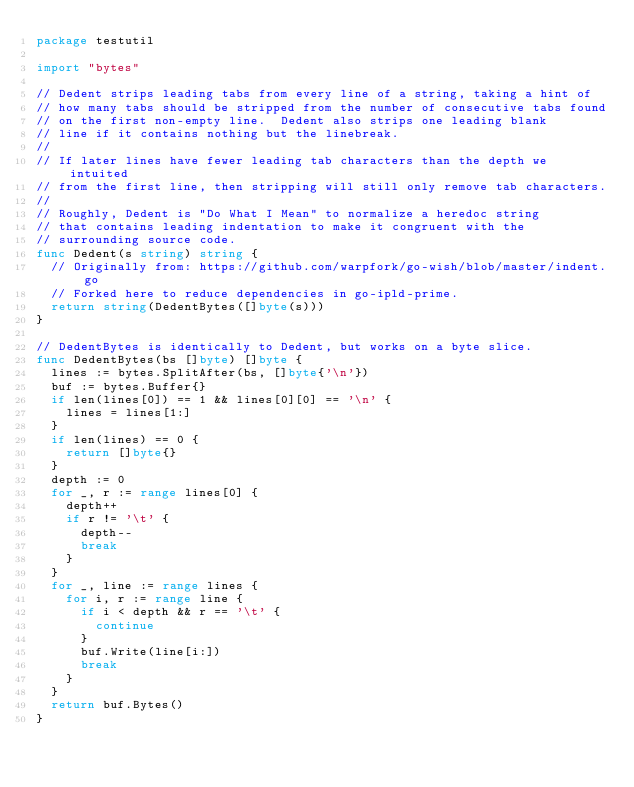<code> <loc_0><loc_0><loc_500><loc_500><_Go_>package testutil

import "bytes"

// Dedent strips leading tabs from every line of a string, taking a hint of
// how many tabs should be stripped from the number of consecutive tabs found
// on the first non-empty line.  Dedent also strips one leading blank
// line if it contains nothing but the linebreak.
//
// If later lines have fewer leading tab characters than the depth we intuited
// from the first line, then stripping will still only remove tab characters.
//
// Roughly, Dedent is "Do What I Mean" to normalize a heredoc string
// that contains leading indentation to make it congruent with the
// surrounding source code.
func Dedent(s string) string {
	// Originally from: https://github.com/warpfork/go-wish/blob/master/indent.go
	// Forked here to reduce dependencies in go-ipld-prime.
	return string(DedentBytes([]byte(s)))
}

// DedentBytes is identically to Dedent, but works on a byte slice.
func DedentBytes(bs []byte) []byte {
	lines := bytes.SplitAfter(bs, []byte{'\n'})
	buf := bytes.Buffer{}
	if len(lines[0]) == 1 && lines[0][0] == '\n' {
		lines = lines[1:]
	}
	if len(lines) == 0 {
		return []byte{}
	}
	depth := 0
	for _, r := range lines[0] {
		depth++
		if r != '\t' {
			depth--
			break
		}
	}
	for _, line := range lines {
		for i, r := range line {
			if i < depth && r == '\t' {
				continue
			}
			buf.Write(line[i:])
			break
		}
	}
	return buf.Bytes()
}
</code> 